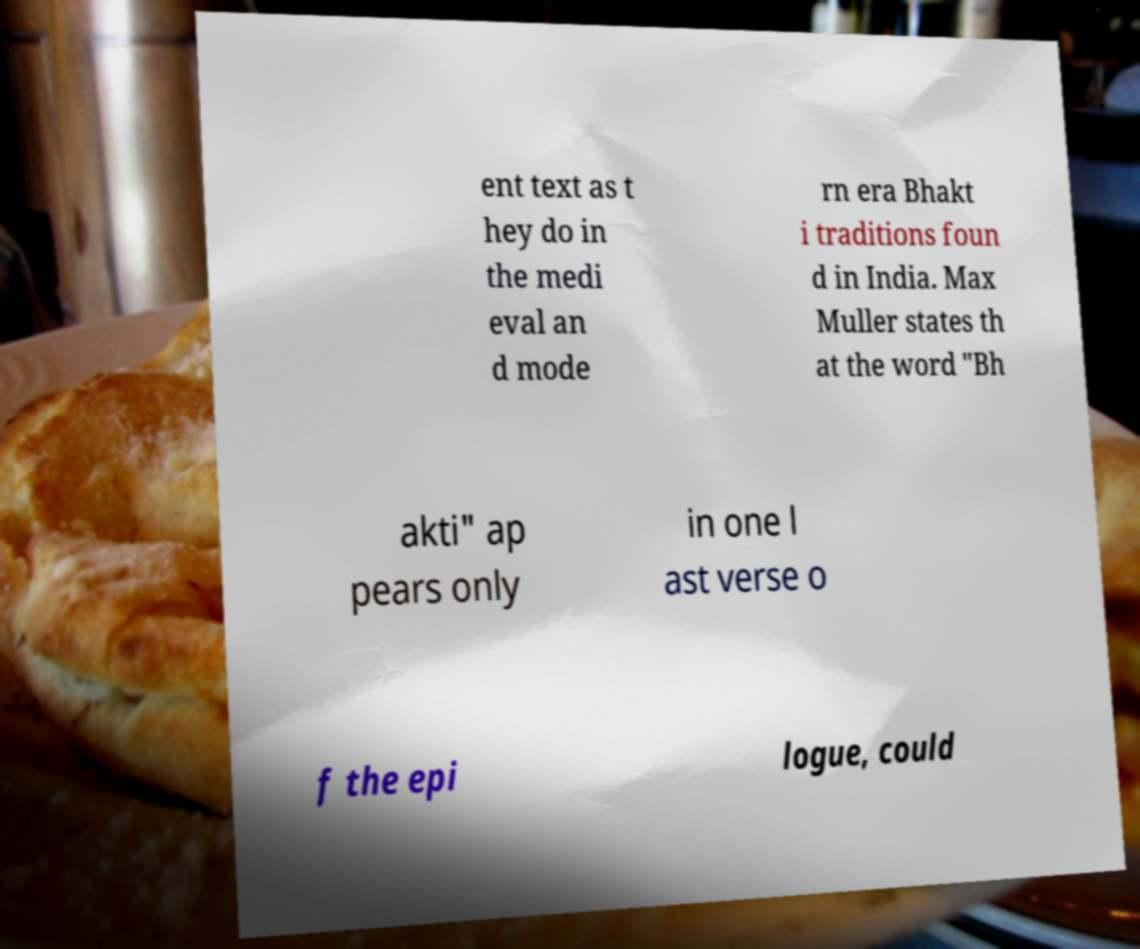Can you read and provide the text displayed in the image?This photo seems to have some interesting text. Can you extract and type it out for me? ent text as t hey do in the medi eval an d mode rn era Bhakt i traditions foun d in India. Max Muller states th at the word "Bh akti" ap pears only in one l ast verse o f the epi logue, could 